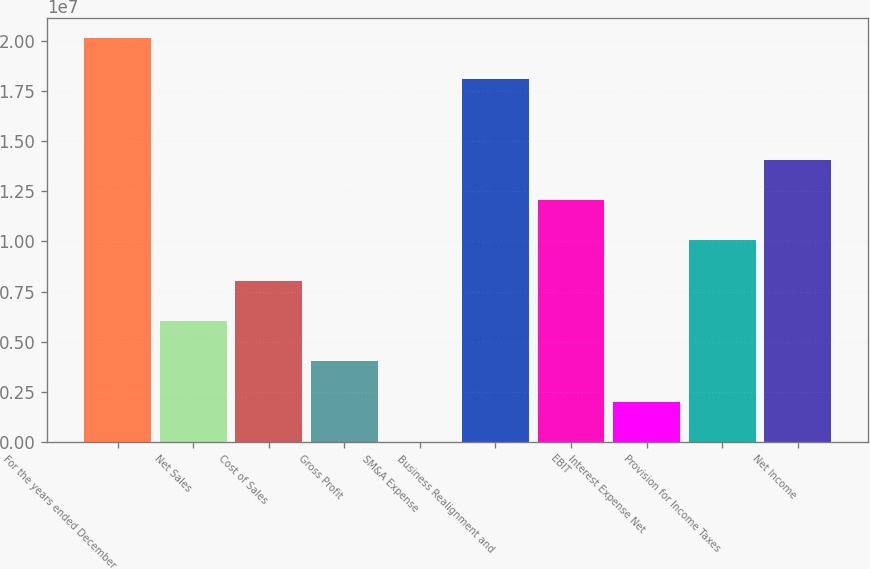<chart> <loc_0><loc_0><loc_500><loc_500><bar_chart><fcel>For the years ended December<fcel>Net Sales<fcel>Cost of Sales<fcel>Gross Profit<fcel>SM&A Expense<fcel>Business Realignment and<fcel>EBIT<fcel>Interest Expense Net<fcel>Provision for Income Taxes<fcel>Net Income<nl><fcel>2.0112e+07<fcel>6.03361e+06<fcel>8.04481e+06<fcel>4.0224e+06<fcel>3.6<fcel>1.81008e+07<fcel>1.20672e+07<fcel>2.0112e+06<fcel>1.0056e+07<fcel>1.40784e+07<nl></chart> 